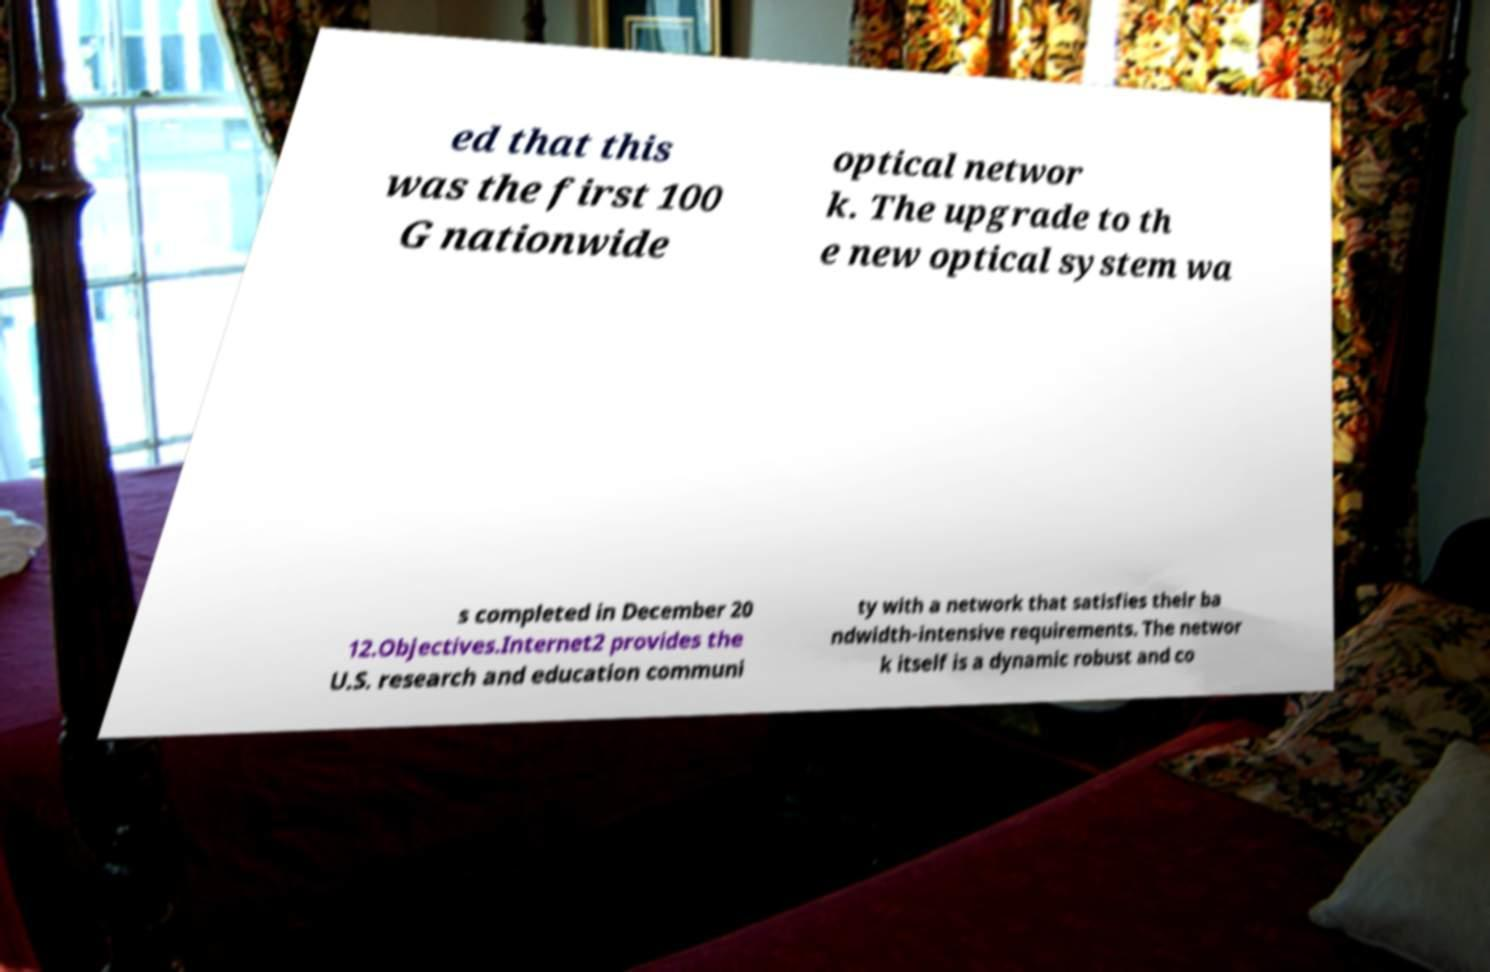Could you assist in decoding the text presented in this image and type it out clearly? ed that this was the first 100 G nationwide optical networ k. The upgrade to th e new optical system wa s completed in December 20 12.Objectives.Internet2 provides the U.S. research and education communi ty with a network that satisfies their ba ndwidth-intensive requirements. The networ k itself is a dynamic robust and co 